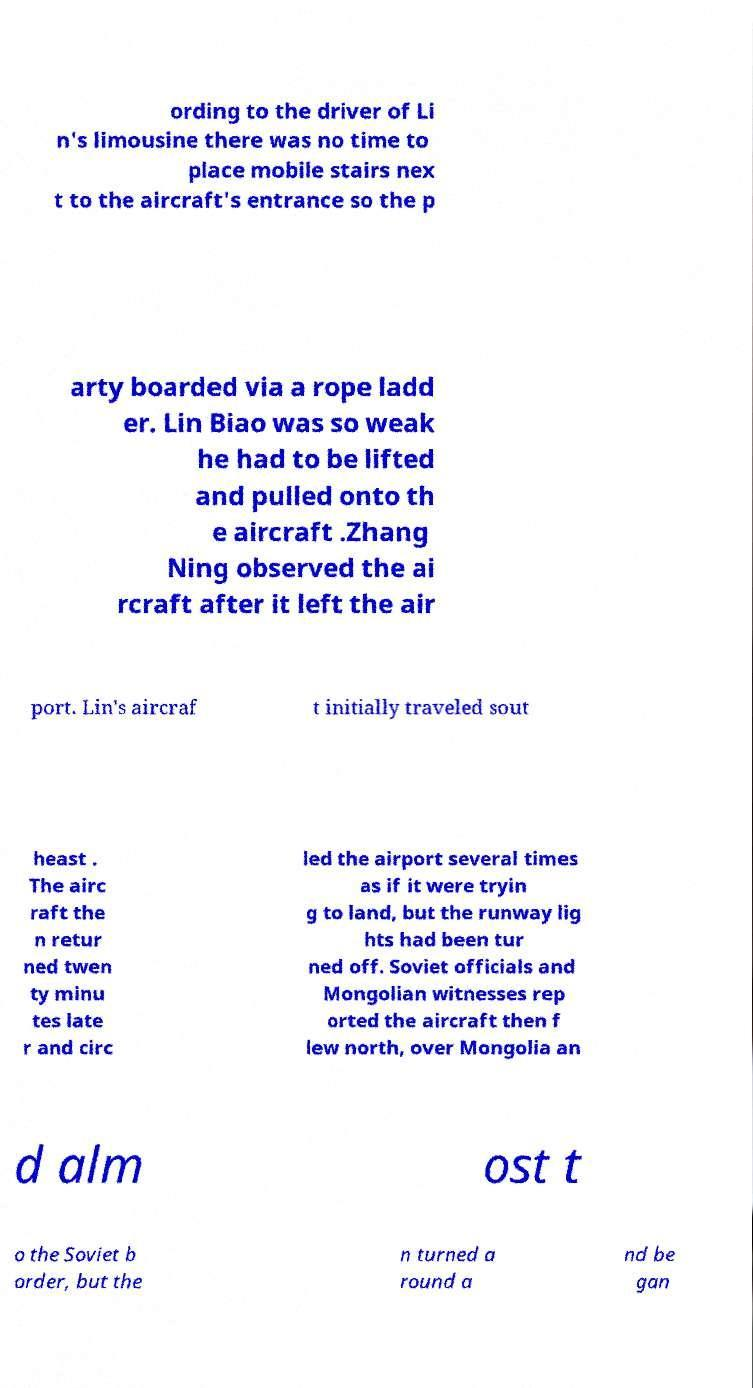I need the written content from this picture converted into text. Can you do that? ording to the driver of Li n's limousine there was no time to place mobile stairs nex t to the aircraft's entrance so the p arty boarded via a rope ladd er. Lin Biao was so weak he had to be lifted and pulled onto th e aircraft .Zhang Ning observed the ai rcraft after it left the air port. Lin's aircraf t initially traveled sout heast . The airc raft the n retur ned twen ty minu tes late r and circ led the airport several times as if it were tryin g to land, but the runway lig hts had been tur ned off. Soviet officials and Mongolian witnesses rep orted the aircraft then f lew north, over Mongolia an d alm ost t o the Soviet b order, but the n turned a round a nd be gan 